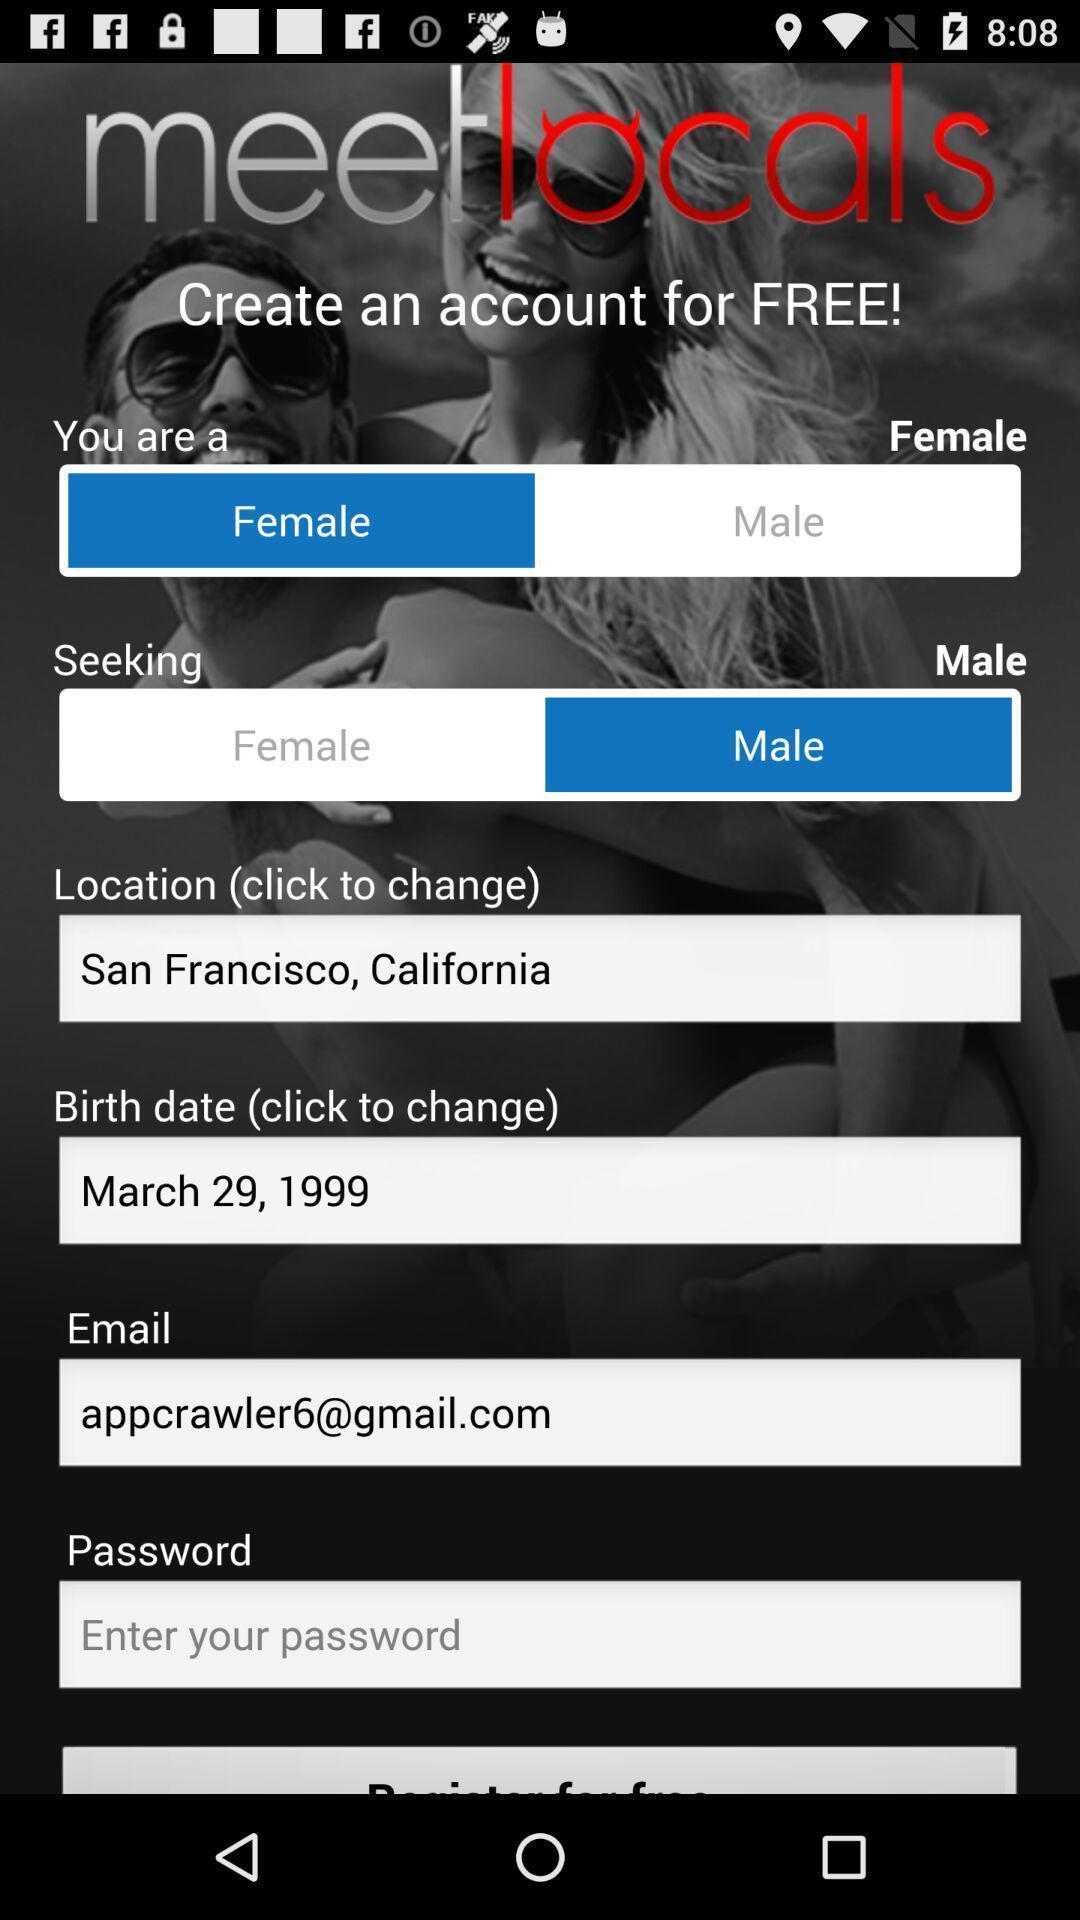Tell me what you see in this picture. Social app for dating and chatting. 